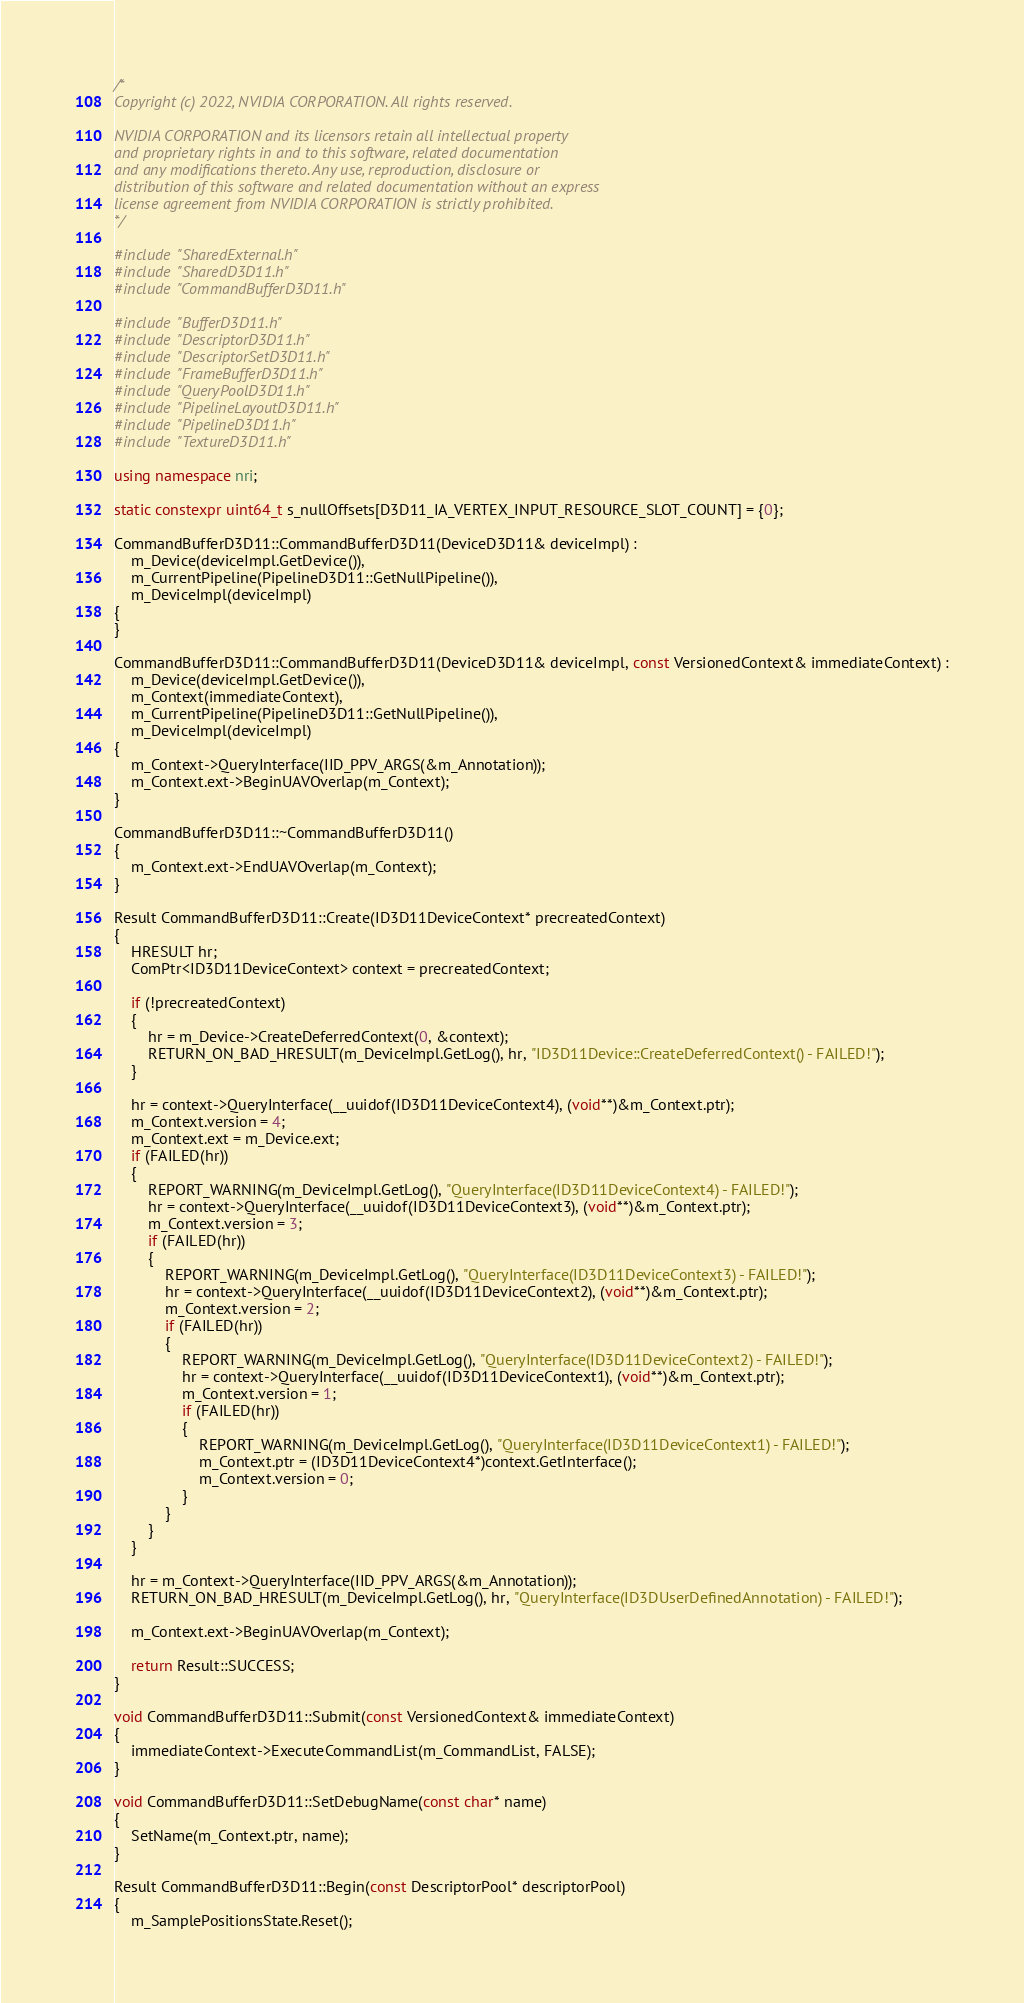<code> <loc_0><loc_0><loc_500><loc_500><_C++_>/*
Copyright (c) 2022, NVIDIA CORPORATION. All rights reserved.

NVIDIA CORPORATION and its licensors retain all intellectual property
and proprietary rights in and to this software, related documentation
and any modifications thereto. Any use, reproduction, disclosure or
distribution of this software and related documentation without an express
license agreement from NVIDIA CORPORATION is strictly prohibited.
*/

#include "SharedExternal.h"
#include "SharedD3D11.h"
#include "CommandBufferD3D11.h"

#include "BufferD3D11.h"
#include "DescriptorD3D11.h"
#include "DescriptorSetD3D11.h"
#include "FrameBufferD3D11.h"
#include "QueryPoolD3D11.h"
#include "PipelineLayoutD3D11.h"
#include "PipelineD3D11.h"
#include "TextureD3D11.h"

using namespace nri;

static constexpr uint64_t s_nullOffsets[D3D11_IA_VERTEX_INPUT_RESOURCE_SLOT_COUNT] = {0};

CommandBufferD3D11::CommandBufferD3D11(DeviceD3D11& deviceImpl) :
    m_Device(deviceImpl.GetDevice()),
    m_CurrentPipeline(PipelineD3D11::GetNullPipeline()),
    m_DeviceImpl(deviceImpl)
{
}

CommandBufferD3D11::CommandBufferD3D11(DeviceD3D11& deviceImpl, const VersionedContext& immediateContext) :
    m_Device(deviceImpl.GetDevice()),
    m_Context(immediateContext),
    m_CurrentPipeline(PipelineD3D11::GetNullPipeline()),
    m_DeviceImpl(deviceImpl)
{
    m_Context->QueryInterface(IID_PPV_ARGS(&m_Annotation));
    m_Context.ext->BeginUAVOverlap(m_Context);
}

CommandBufferD3D11::~CommandBufferD3D11()
{
    m_Context.ext->EndUAVOverlap(m_Context);
}

Result CommandBufferD3D11::Create(ID3D11DeviceContext* precreatedContext)
{
    HRESULT hr;
    ComPtr<ID3D11DeviceContext> context = precreatedContext;

    if (!precreatedContext)
    {
        hr = m_Device->CreateDeferredContext(0, &context);
        RETURN_ON_BAD_HRESULT(m_DeviceImpl.GetLog(), hr, "ID3D11Device::CreateDeferredContext() - FAILED!");
    }

    hr = context->QueryInterface(__uuidof(ID3D11DeviceContext4), (void**)&m_Context.ptr);
    m_Context.version = 4;
    m_Context.ext = m_Device.ext;
    if (FAILED(hr))
    {
        REPORT_WARNING(m_DeviceImpl.GetLog(), "QueryInterface(ID3D11DeviceContext4) - FAILED!");
        hr = context->QueryInterface(__uuidof(ID3D11DeviceContext3), (void**)&m_Context.ptr);
        m_Context.version = 3;
        if (FAILED(hr))
        {
            REPORT_WARNING(m_DeviceImpl.GetLog(), "QueryInterface(ID3D11DeviceContext3) - FAILED!");
            hr = context->QueryInterface(__uuidof(ID3D11DeviceContext2), (void**)&m_Context.ptr);
            m_Context.version = 2;
            if (FAILED(hr))
            {
                REPORT_WARNING(m_DeviceImpl.GetLog(), "QueryInterface(ID3D11DeviceContext2) - FAILED!");
                hr = context->QueryInterface(__uuidof(ID3D11DeviceContext1), (void**)&m_Context.ptr);
                m_Context.version = 1;
                if (FAILED(hr))
                {
                    REPORT_WARNING(m_DeviceImpl.GetLog(), "QueryInterface(ID3D11DeviceContext1) - FAILED!");
                    m_Context.ptr = (ID3D11DeviceContext4*)context.GetInterface();
                    m_Context.version = 0;
                }
            }
        }
    }

    hr = m_Context->QueryInterface(IID_PPV_ARGS(&m_Annotation));
    RETURN_ON_BAD_HRESULT(m_DeviceImpl.GetLog(), hr, "QueryInterface(ID3DUserDefinedAnnotation) - FAILED!");

    m_Context.ext->BeginUAVOverlap(m_Context);

    return Result::SUCCESS;
}

void CommandBufferD3D11::Submit(const VersionedContext& immediateContext)
{
    immediateContext->ExecuteCommandList(m_CommandList, FALSE);
}

void CommandBufferD3D11::SetDebugName(const char* name)
{
    SetName(m_Context.ptr, name);
}

Result CommandBufferD3D11::Begin(const DescriptorPool* descriptorPool)
{
    m_SamplePositionsState.Reset();</code> 